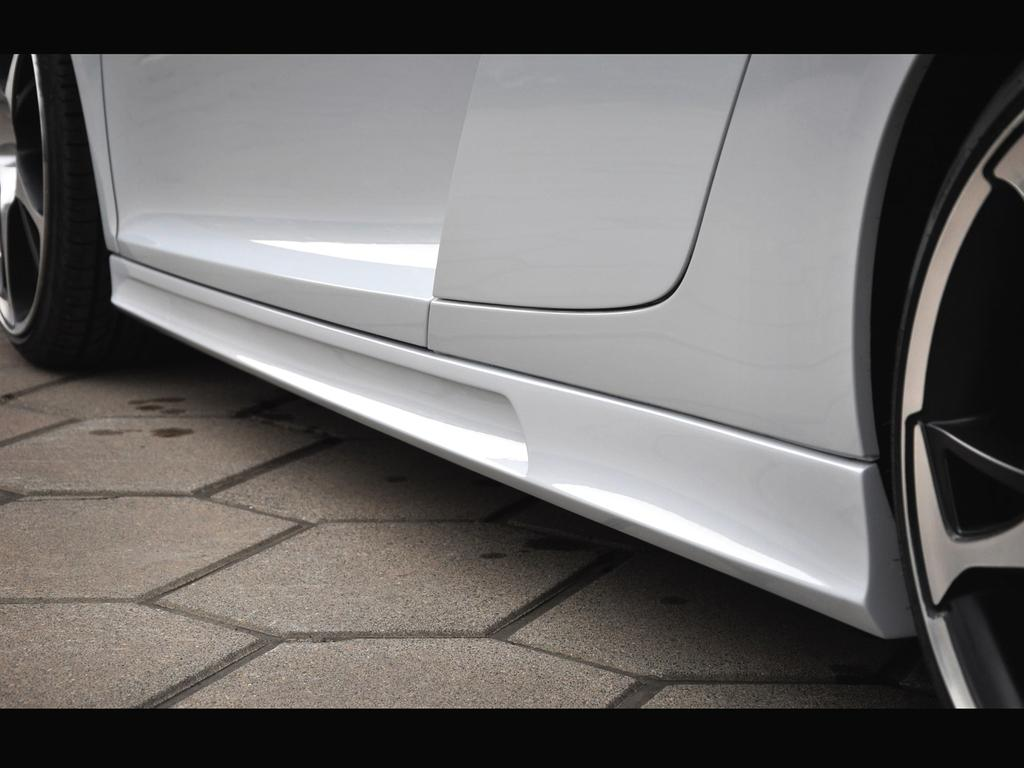What is the main subject of the picture? The main subject of the picture is a car. Can you describe the color of the car? The car is white in color. What type of form or vase can be seen on the road in the image? There is no form or vase present in the image, and the image does not show a road. 